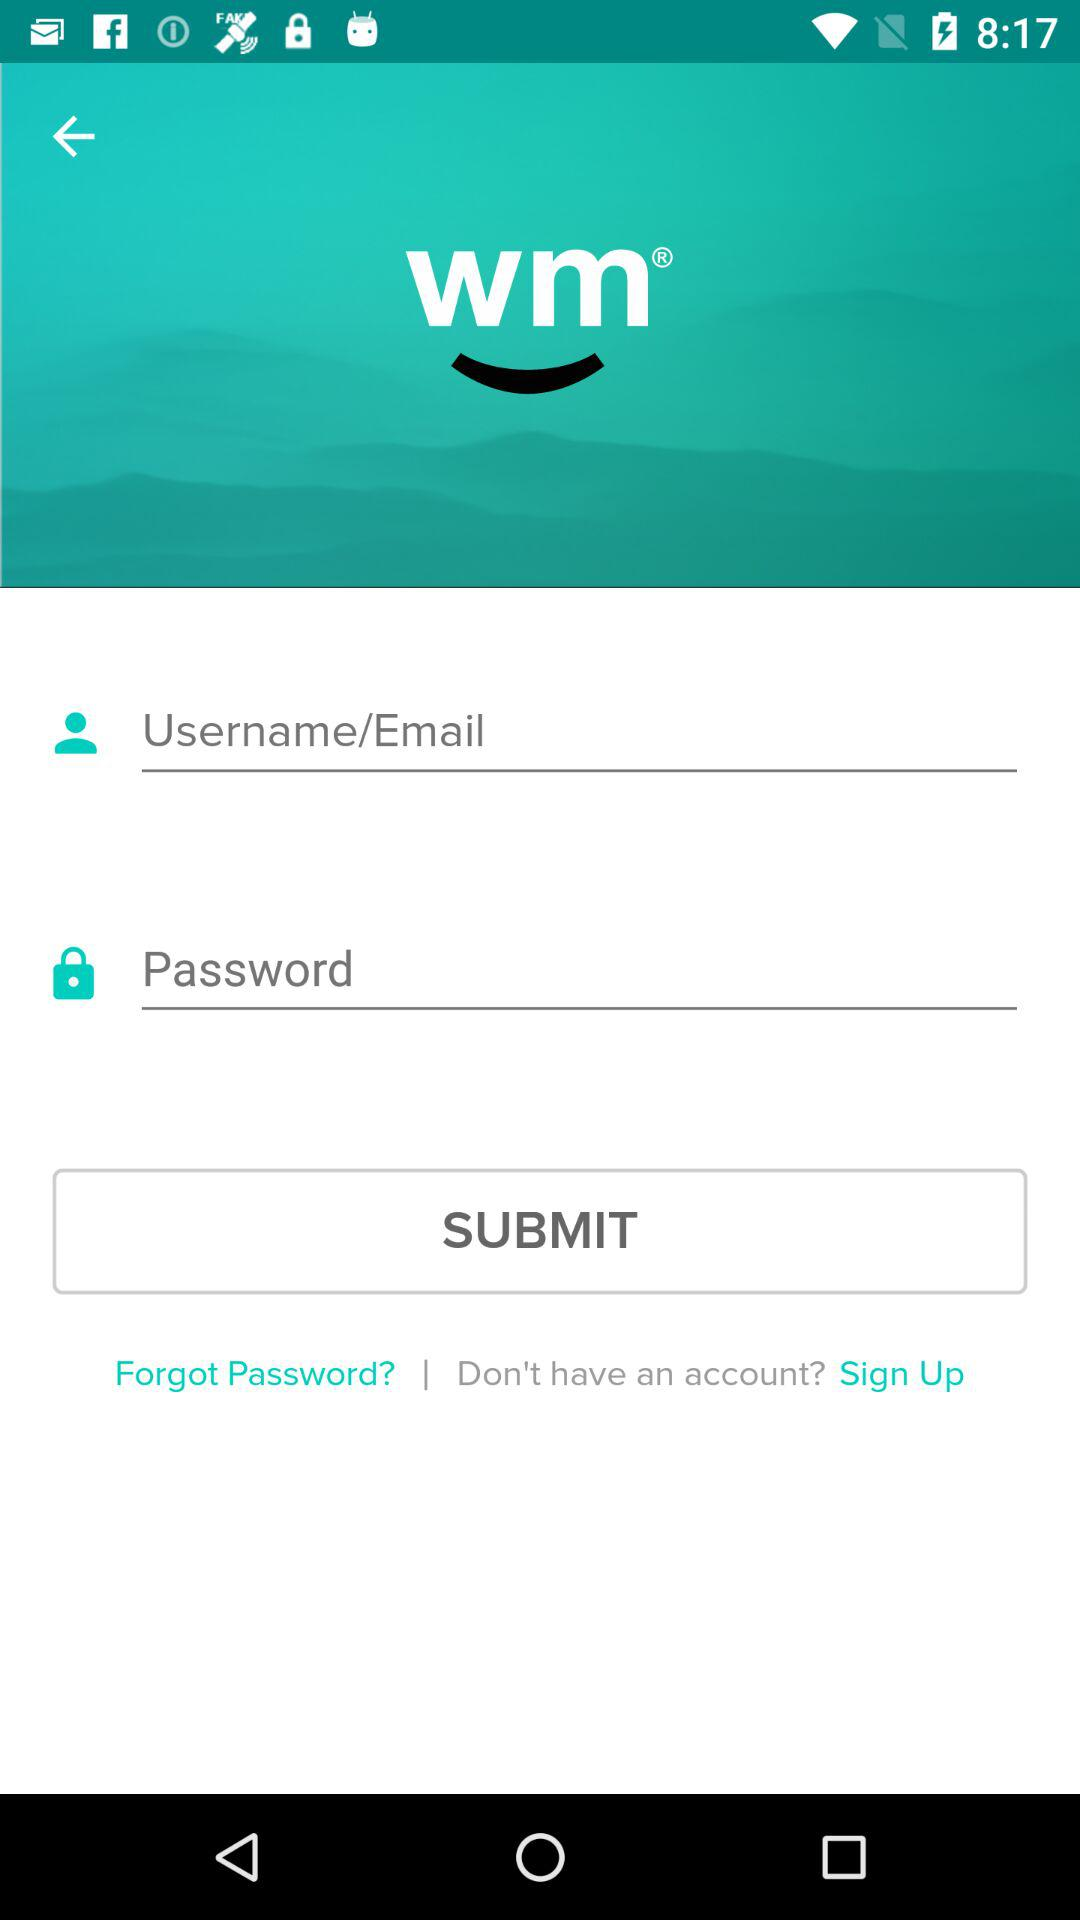Can we reset password?
When the provided information is insufficient, respond with <no answer>. <no answer> 